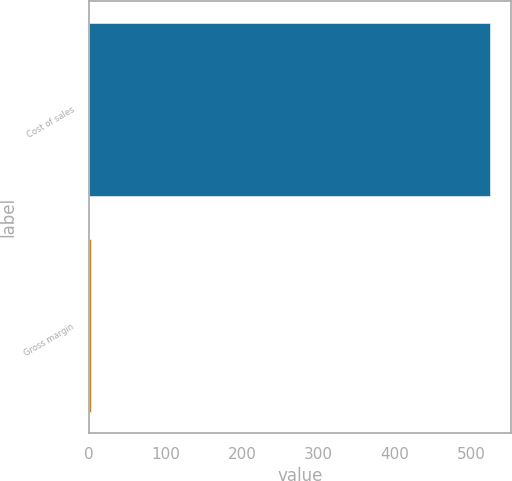<chart> <loc_0><loc_0><loc_500><loc_500><bar_chart><fcel>Cost of sales<fcel>Gross margin<nl><fcel>525<fcel>3<nl></chart> 